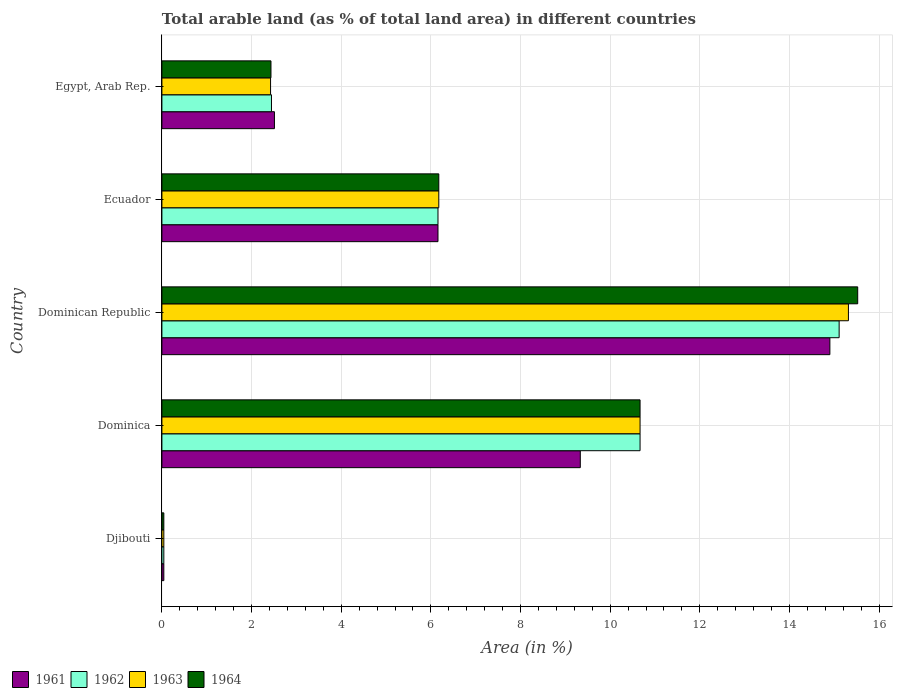How many different coloured bars are there?
Provide a short and direct response. 4. How many groups of bars are there?
Offer a terse response. 5. Are the number of bars on each tick of the Y-axis equal?
Your answer should be compact. Yes. How many bars are there on the 2nd tick from the top?
Keep it short and to the point. 4. What is the label of the 3rd group of bars from the top?
Provide a succinct answer. Dominican Republic. In how many cases, is the number of bars for a given country not equal to the number of legend labels?
Ensure brevity in your answer.  0. What is the percentage of arable land in 1964 in Dominica?
Your answer should be very brief. 10.67. Across all countries, what is the maximum percentage of arable land in 1961?
Provide a short and direct response. 14.9. Across all countries, what is the minimum percentage of arable land in 1962?
Offer a very short reply. 0.04. In which country was the percentage of arable land in 1961 maximum?
Your answer should be compact. Dominican Republic. In which country was the percentage of arable land in 1964 minimum?
Provide a short and direct response. Djibouti. What is the total percentage of arable land in 1961 in the graph?
Give a very brief answer. 32.95. What is the difference between the percentage of arable land in 1963 in Dominica and that in Dominican Republic?
Your answer should be very brief. -4.65. What is the difference between the percentage of arable land in 1963 in Egypt, Arab Rep. and the percentage of arable land in 1964 in Ecuador?
Your answer should be very brief. -3.75. What is the average percentage of arable land in 1961 per country?
Offer a terse response. 6.59. What is the difference between the percentage of arable land in 1961 and percentage of arable land in 1962 in Ecuador?
Your response must be concise. 0. In how many countries, is the percentage of arable land in 1963 greater than 6 %?
Offer a terse response. 3. What is the ratio of the percentage of arable land in 1961 in Ecuador to that in Egypt, Arab Rep.?
Give a very brief answer. 2.45. What is the difference between the highest and the second highest percentage of arable land in 1961?
Your answer should be compact. 5.57. What is the difference between the highest and the lowest percentage of arable land in 1961?
Give a very brief answer. 14.86. In how many countries, is the percentage of arable land in 1962 greater than the average percentage of arable land in 1962 taken over all countries?
Your answer should be compact. 2. Is it the case that in every country, the sum of the percentage of arable land in 1962 and percentage of arable land in 1964 is greater than the sum of percentage of arable land in 1963 and percentage of arable land in 1961?
Make the answer very short. No. What does the 3rd bar from the top in Djibouti represents?
Keep it short and to the point. 1962. Is it the case that in every country, the sum of the percentage of arable land in 1963 and percentage of arable land in 1964 is greater than the percentage of arable land in 1961?
Keep it short and to the point. Yes. How many bars are there?
Offer a terse response. 20. Are all the bars in the graph horizontal?
Keep it short and to the point. Yes. How many countries are there in the graph?
Keep it short and to the point. 5. What is the difference between two consecutive major ticks on the X-axis?
Make the answer very short. 2. Does the graph contain any zero values?
Keep it short and to the point. No. Does the graph contain grids?
Keep it short and to the point. Yes. How many legend labels are there?
Ensure brevity in your answer.  4. What is the title of the graph?
Ensure brevity in your answer.  Total arable land (as % of total land area) in different countries. What is the label or title of the X-axis?
Provide a succinct answer. Area (in %). What is the Area (in %) in 1961 in Djibouti?
Make the answer very short. 0.04. What is the Area (in %) of 1962 in Djibouti?
Provide a short and direct response. 0.04. What is the Area (in %) in 1963 in Djibouti?
Keep it short and to the point. 0.04. What is the Area (in %) in 1964 in Djibouti?
Give a very brief answer. 0.04. What is the Area (in %) of 1961 in Dominica?
Offer a very short reply. 9.33. What is the Area (in %) of 1962 in Dominica?
Provide a short and direct response. 10.67. What is the Area (in %) of 1963 in Dominica?
Make the answer very short. 10.67. What is the Area (in %) in 1964 in Dominica?
Offer a very short reply. 10.67. What is the Area (in %) in 1961 in Dominican Republic?
Offer a very short reply. 14.9. What is the Area (in %) in 1962 in Dominican Republic?
Keep it short and to the point. 15.11. What is the Area (in %) in 1963 in Dominican Republic?
Your answer should be compact. 15.31. What is the Area (in %) of 1964 in Dominican Republic?
Provide a succinct answer. 15.52. What is the Area (in %) of 1961 in Ecuador?
Your answer should be compact. 6.16. What is the Area (in %) in 1962 in Ecuador?
Offer a terse response. 6.16. What is the Area (in %) in 1963 in Ecuador?
Your answer should be very brief. 6.18. What is the Area (in %) in 1964 in Ecuador?
Ensure brevity in your answer.  6.18. What is the Area (in %) in 1961 in Egypt, Arab Rep.?
Provide a succinct answer. 2.51. What is the Area (in %) in 1962 in Egypt, Arab Rep.?
Your response must be concise. 2.44. What is the Area (in %) in 1963 in Egypt, Arab Rep.?
Offer a very short reply. 2.42. What is the Area (in %) of 1964 in Egypt, Arab Rep.?
Your answer should be compact. 2.43. Across all countries, what is the maximum Area (in %) in 1961?
Your response must be concise. 14.9. Across all countries, what is the maximum Area (in %) in 1962?
Your answer should be compact. 15.11. Across all countries, what is the maximum Area (in %) in 1963?
Make the answer very short. 15.31. Across all countries, what is the maximum Area (in %) in 1964?
Your answer should be very brief. 15.52. Across all countries, what is the minimum Area (in %) of 1961?
Keep it short and to the point. 0.04. Across all countries, what is the minimum Area (in %) in 1962?
Ensure brevity in your answer.  0.04. Across all countries, what is the minimum Area (in %) of 1963?
Offer a very short reply. 0.04. Across all countries, what is the minimum Area (in %) of 1964?
Provide a succinct answer. 0.04. What is the total Area (in %) of 1961 in the graph?
Give a very brief answer. 32.95. What is the total Area (in %) of 1962 in the graph?
Ensure brevity in your answer.  34.42. What is the total Area (in %) in 1963 in the graph?
Your answer should be very brief. 34.63. What is the total Area (in %) of 1964 in the graph?
Keep it short and to the point. 34.84. What is the difference between the Area (in %) of 1961 in Djibouti and that in Dominica?
Give a very brief answer. -9.29. What is the difference between the Area (in %) in 1962 in Djibouti and that in Dominica?
Give a very brief answer. -10.62. What is the difference between the Area (in %) in 1963 in Djibouti and that in Dominica?
Offer a very short reply. -10.62. What is the difference between the Area (in %) of 1964 in Djibouti and that in Dominica?
Keep it short and to the point. -10.62. What is the difference between the Area (in %) of 1961 in Djibouti and that in Dominican Republic?
Offer a very short reply. -14.86. What is the difference between the Area (in %) in 1962 in Djibouti and that in Dominican Republic?
Offer a very short reply. -15.06. What is the difference between the Area (in %) of 1963 in Djibouti and that in Dominican Republic?
Your answer should be compact. -15.27. What is the difference between the Area (in %) of 1964 in Djibouti and that in Dominican Republic?
Your response must be concise. -15.48. What is the difference between the Area (in %) in 1961 in Djibouti and that in Ecuador?
Offer a terse response. -6.12. What is the difference between the Area (in %) of 1962 in Djibouti and that in Ecuador?
Provide a succinct answer. -6.12. What is the difference between the Area (in %) of 1963 in Djibouti and that in Ecuador?
Provide a succinct answer. -6.13. What is the difference between the Area (in %) of 1964 in Djibouti and that in Ecuador?
Your answer should be compact. -6.13. What is the difference between the Area (in %) of 1961 in Djibouti and that in Egypt, Arab Rep.?
Offer a very short reply. -2.47. What is the difference between the Area (in %) of 1962 in Djibouti and that in Egypt, Arab Rep.?
Provide a succinct answer. -2.4. What is the difference between the Area (in %) in 1963 in Djibouti and that in Egypt, Arab Rep.?
Your answer should be very brief. -2.38. What is the difference between the Area (in %) of 1964 in Djibouti and that in Egypt, Arab Rep.?
Your response must be concise. -2.39. What is the difference between the Area (in %) of 1961 in Dominica and that in Dominican Republic?
Offer a very short reply. -5.57. What is the difference between the Area (in %) in 1962 in Dominica and that in Dominican Republic?
Offer a very short reply. -4.44. What is the difference between the Area (in %) in 1963 in Dominica and that in Dominican Republic?
Offer a very short reply. -4.65. What is the difference between the Area (in %) in 1964 in Dominica and that in Dominican Republic?
Provide a short and direct response. -4.85. What is the difference between the Area (in %) of 1961 in Dominica and that in Ecuador?
Provide a succinct answer. 3.17. What is the difference between the Area (in %) in 1962 in Dominica and that in Ecuador?
Provide a succinct answer. 4.51. What is the difference between the Area (in %) of 1963 in Dominica and that in Ecuador?
Ensure brevity in your answer.  4.49. What is the difference between the Area (in %) in 1964 in Dominica and that in Ecuador?
Your answer should be compact. 4.49. What is the difference between the Area (in %) in 1961 in Dominica and that in Egypt, Arab Rep.?
Offer a very short reply. 6.82. What is the difference between the Area (in %) of 1962 in Dominica and that in Egypt, Arab Rep.?
Your response must be concise. 8.22. What is the difference between the Area (in %) of 1963 in Dominica and that in Egypt, Arab Rep.?
Offer a terse response. 8.24. What is the difference between the Area (in %) of 1964 in Dominica and that in Egypt, Arab Rep.?
Your response must be concise. 8.23. What is the difference between the Area (in %) of 1961 in Dominican Republic and that in Ecuador?
Provide a short and direct response. 8.74. What is the difference between the Area (in %) in 1962 in Dominican Republic and that in Ecuador?
Keep it short and to the point. 8.95. What is the difference between the Area (in %) of 1963 in Dominican Republic and that in Ecuador?
Provide a short and direct response. 9.14. What is the difference between the Area (in %) in 1964 in Dominican Republic and that in Ecuador?
Ensure brevity in your answer.  9.34. What is the difference between the Area (in %) of 1961 in Dominican Republic and that in Egypt, Arab Rep.?
Provide a succinct answer. 12.39. What is the difference between the Area (in %) in 1962 in Dominican Republic and that in Egypt, Arab Rep.?
Provide a succinct answer. 12.66. What is the difference between the Area (in %) of 1963 in Dominican Republic and that in Egypt, Arab Rep.?
Keep it short and to the point. 12.89. What is the difference between the Area (in %) of 1964 in Dominican Republic and that in Egypt, Arab Rep.?
Your answer should be compact. 13.09. What is the difference between the Area (in %) in 1961 in Ecuador and that in Egypt, Arab Rep.?
Keep it short and to the point. 3.65. What is the difference between the Area (in %) in 1962 in Ecuador and that in Egypt, Arab Rep.?
Provide a short and direct response. 3.71. What is the difference between the Area (in %) in 1963 in Ecuador and that in Egypt, Arab Rep.?
Make the answer very short. 3.75. What is the difference between the Area (in %) in 1964 in Ecuador and that in Egypt, Arab Rep.?
Ensure brevity in your answer.  3.74. What is the difference between the Area (in %) in 1961 in Djibouti and the Area (in %) in 1962 in Dominica?
Make the answer very short. -10.62. What is the difference between the Area (in %) of 1961 in Djibouti and the Area (in %) of 1963 in Dominica?
Provide a short and direct response. -10.62. What is the difference between the Area (in %) of 1961 in Djibouti and the Area (in %) of 1964 in Dominica?
Ensure brevity in your answer.  -10.62. What is the difference between the Area (in %) in 1962 in Djibouti and the Area (in %) in 1963 in Dominica?
Keep it short and to the point. -10.62. What is the difference between the Area (in %) of 1962 in Djibouti and the Area (in %) of 1964 in Dominica?
Give a very brief answer. -10.62. What is the difference between the Area (in %) of 1963 in Djibouti and the Area (in %) of 1964 in Dominica?
Offer a very short reply. -10.62. What is the difference between the Area (in %) in 1961 in Djibouti and the Area (in %) in 1962 in Dominican Republic?
Offer a very short reply. -15.06. What is the difference between the Area (in %) of 1961 in Djibouti and the Area (in %) of 1963 in Dominican Republic?
Offer a terse response. -15.27. What is the difference between the Area (in %) of 1961 in Djibouti and the Area (in %) of 1964 in Dominican Republic?
Keep it short and to the point. -15.48. What is the difference between the Area (in %) in 1962 in Djibouti and the Area (in %) in 1963 in Dominican Republic?
Provide a short and direct response. -15.27. What is the difference between the Area (in %) in 1962 in Djibouti and the Area (in %) in 1964 in Dominican Republic?
Provide a succinct answer. -15.48. What is the difference between the Area (in %) in 1963 in Djibouti and the Area (in %) in 1964 in Dominican Republic?
Make the answer very short. -15.48. What is the difference between the Area (in %) of 1961 in Djibouti and the Area (in %) of 1962 in Ecuador?
Provide a short and direct response. -6.12. What is the difference between the Area (in %) in 1961 in Djibouti and the Area (in %) in 1963 in Ecuador?
Provide a succinct answer. -6.13. What is the difference between the Area (in %) of 1961 in Djibouti and the Area (in %) of 1964 in Ecuador?
Your answer should be compact. -6.13. What is the difference between the Area (in %) of 1962 in Djibouti and the Area (in %) of 1963 in Ecuador?
Your answer should be compact. -6.13. What is the difference between the Area (in %) of 1962 in Djibouti and the Area (in %) of 1964 in Ecuador?
Provide a succinct answer. -6.13. What is the difference between the Area (in %) of 1963 in Djibouti and the Area (in %) of 1964 in Ecuador?
Your response must be concise. -6.13. What is the difference between the Area (in %) in 1961 in Djibouti and the Area (in %) in 1962 in Egypt, Arab Rep.?
Your answer should be very brief. -2.4. What is the difference between the Area (in %) of 1961 in Djibouti and the Area (in %) of 1963 in Egypt, Arab Rep.?
Offer a terse response. -2.38. What is the difference between the Area (in %) in 1961 in Djibouti and the Area (in %) in 1964 in Egypt, Arab Rep.?
Your response must be concise. -2.39. What is the difference between the Area (in %) of 1962 in Djibouti and the Area (in %) of 1963 in Egypt, Arab Rep.?
Offer a terse response. -2.38. What is the difference between the Area (in %) in 1962 in Djibouti and the Area (in %) in 1964 in Egypt, Arab Rep.?
Ensure brevity in your answer.  -2.39. What is the difference between the Area (in %) of 1963 in Djibouti and the Area (in %) of 1964 in Egypt, Arab Rep.?
Give a very brief answer. -2.39. What is the difference between the Area (in %) in 1961 in Dominica and the Area (in %) in 1962 in Dominican Republic?
Your answer should be compact. -5.77. What is the difference between the Area (in %) of 1961 in Dominica and the Area (in %) of 1963 in Dominican Republic?
Make the answer very short. -5.98. What is the difference between the Area (in %) in 1961 in Dominica and the Area (in %) in 1964 in Dominican Republic?
Your answer should be very brief. -6.19. What is the difference between the Area (in %) of 1962 in Dominica and the Area (in %) of 1963 in Dominican Republic?
Make the answer very short. -4.65. What is the difference between the Area (in %) in 1962 in Dominica and the Area (in %) in 1964 in Dominican Republic?
Offer a terse response. -4.85. What is the difference between the Area (in %) in 1963 in Dominica and the Area (in %) in 1964 in Dominican Republic?
Offer a very short reply. -4.85. What is the difference between the Area (in %) of 1961 in Dominica and the Area (in %) of 1962 in Ecuador?
Offer a terse response. 3.17. What is the difference between the Area (in %) of 1961 in Dominica and the Area (in %) of 1963 in Ecuador?
Your answer should be very brief. 3.16. What is the difference between the Area (in %) in 1961 in Dominica and the Area (in %) in 1964 in Ecuador?
Your response must be concise. 3.16. What is the difference between the Area (in %) of 1962 in Dominica and the Area (in %) of 1963 in Ecuador?
Your answer should be compact. 4.49. What is the difference between the Area (in %) of 1962 in Dominica and the Area (in %) of 1964 in Ecuador?
Provide a short and direct response. 4.49. What is the difference between the Area (in %) of 1963 in Dominica and the Area (in %) of 1964 in Ecuador?
Provide a succinct answer. 4.49. What is the difference between the Area (in %) of 1961 in Dominica and the Area (in %) of 1962 in Egypt, Arab Rep.?
Keep it short and to the point. 6.89. What is the difference between the Area (in %) in 1961 in Dominica and the Area (in %) in 1963 in Egypt, Arab Rep.?
Offer a very short reply. 6.91. What is the difference between the Area (in %) in 1961 in Dominica and the Area (in %) in 1964 in Egypt, Arab Rep.?
Your answer should be compact. 6.9. What is the difference between the Area (in %) in 1962 in Dominica and the Area (in %) in 1963 in Egypt, Arab Rep.?
Keep it short and to the point. 8.24. What is the difference between the Area (in %) of 1962 in Dominica and the Area (in %) of 1964 in Egypt, Arab Rep.?
Provide a succinct answer. 8.23. What is the difference between the Area (in %) of 1963 in Dominica and the Area (in %) of 1964 in Egypt, Arab Rep.?
Offer a very short reply. 8.23. What is the difference between the Area (in %) in 1961 in Dominican Republic and the Area (in %) in 1962 in Ecuador?
Your answer should be very brief. 8.74. What is the difference between the Area (in %) of 1961 in Dominican Republic and the Area (in %) of 1963 in Ecuador?
Keep it short and to the point. 8.72. What is the difference between the Area (in %) in 1961 in Dominican Republic and the Area (in %) in 1964 in Ecuador?
Your response must be concise. 8.72. What is the difference between the Area (in %) of 1962 in Dominican Republic and the Area (in %) of 1963 in Ecuador?
Keep it short and to the point. 8.93. What is the difference between the Area (in %) in 1962 in Dominican Republic and the Area (in %) in 1964 in Ecuador?
Provide a succinct answer. 8.93. What is the difference between the Area (in %) of 1963 in Dominican Republic and the Area (in %) of 1964 in Ecuador?
Keep it short and to the point. 9.14. What is the difference between the Area (in %) of 1961 in Dominican Republic and the Area (in %) of 1962 in Egypt, Arab Rep.?
Offer a very short reply. 12.46. What is the difference between the Area (in %) in 1961 in Dominican Republic and the Area (in %) in 1963 in Egypt, Arab Rep.?
Offer a very short reply. 12.48. What is the difference between the Area (in %) of 1961 in Dominican Republic and the Area (in %) of 1964 in Egypt, Arab Rep.?
Make the answer very short. 12.47. What is the difference between the Area (in %) in 1962 in Dominican Republic and the Area (in %) in 1963 in Egypt, Arab Rep.?
Offer a terse response. 12.68. What is the difference between the Area (in %) in 1962 in Dominican Republic and the Area (in %) in 1964 in Egypt, Arab Rep.?
Make the answer very short. 12.67. What is the difference between the Area (in %) of 1963 in Dominican Republic and the Area (in %) of 1964 in Egypt, Arab Rep.?
Offer a terse response. 12.88. What is the difference between the Area (in %) in 1961 in Ecuador and the Area (in %) in 1962 in Egypt, Arab Rep.?
Your answer should be compact. 3.71. What is the difference between the Area (in %) of 1961 in Ecuador and the Area (in %) of 1963 in Egypt, Arab Rep.?
Your answer should be very brief. 3.73. What is the difference between the Area (in %) of 1961 in Ecuador and the Area (in %) of 1964 in Egypt, Arab Rep.?
Keep it short and to the point. 3.73. What is the difference between the Area (in %) of 1962 in Ecuador and the Area (in %) of 1963 in Egypt, Arab Rep.?
Provide a succinct answer. 3.73. What is the difference between the Area (in %) of 1962 in Ecuador and the Area (in %) of 1964 in Egypt, Arab Rep.?
Make the answer very short. 3.73. What is the difference between the Area (in %) in 1963 in Ecuador and the Area (in %) in 1964 in Egypt, Arab Rep.?
Provide a succinct answer. 3.74. What is the average Area (in %) in 1961 per country?
Offer a very short reply. 6.59. What is the average Area (in %) in 1962 per country?
Your response must be concise. 6.88. What is the average Area (in %) of 1963 per country?
Ensure brevity in your answer.  6.93. What is the average Area (in %) in 1964 per country?
Your answer should be very brief. 6.97. What is the difference between the Area (in %) in 1961 and Area (in %) in 1962 in Dominica?
Your answer should be very brief. -1.33. What is the difference between the Area (in %) in 1961 and Area (in %) in 1963 in Dominica?
Make the answer very short. -1.33. What is the difference between the Area (in %) in 1961 and Area (in %) in 1964 in Dominica?
Make the answer very short. -1.33. What is the difference between the Area (in %) of 1962 and Area (in %) of 1963 in Dominica?
Your answer should be very brief. 0. What is the difference between the Area (in %) of 1963 and Area (in %) of 1964 in Dominica?
Your answer should be compact. 0. What is the difference between the Area (in %) in 1961 and Area (in %) in 1962 in Dominican Republic?
Offer a very short reply. -0.21. What is the difference between the Area (in %) in 1961 and Area (in %) in 1963 in Dominican Republic?
Make the answer very short. -0.41. What is the difference between the Area (in %) of 1961 and Area (in %) of 1964 in Dominican Republic?
Provide a short and direct response. -0.62. What is the difference between the Area (in %) in 1962 and Area (in %) in 1963 in Dominican Republic?
Ensure brevity in your answer.  -0.21. What is the difference between the Area (in %) in 1962 and Area (in %) in 1964 in Dominican Republic?
Your answer should be compact. -0.41. What is the difference between the Area (in %) of 1963 and Area (in %) of 1964 in Dominican Republic?
Your answer should be compact. -0.21. What is the difference between the Area (in %) in 1961 and Area (in %) in 1963 in Ecuador?
Keep it short and to the point. -0.02. What is the difference between the Area (in %) in 1961 and Area (in %) in 1964 in Ecuador?
Make the answer very short. -0.02. What is the difference between the Area (in %) in 1962 and Area (in %) in 1963 in Ecuador?
Your answer should be very brief. -0.02. What is the difference between the Area (in %) in 1962 and Area (in %) in 1964 in Ecuador?
Your answer should be compact. -0.02. What is the difference between the Area (in %) of 1961 and Area (in %) of 1962 in Egypt, Arab Rep.?
Make the answer very short. 0.07. What is the difference between the Area (in %) of 1961 and Area (in %) of 1963 in Egypt, Arab Rep.?
Provide a succinct answer. 0.09. What is the difference between the Area (in %) in 1961 and Area (in %) in 1964 in Egypt, Arab Rep.?
Keep it short and to the point. 0.08. What is the difference between the Area (in %) of 1962 and Area (in %) of 1963 in Egypt, Arab Rep.?
Provide a short and direct response. 0.02. What is the difference between the Area (in %) in 1962 and Area (in %) in 1964 in Egypt, Arab Rep.?
Give a very brief answer. 0.01. What is the difference between the Area (in %) of 1963 and Area (in %) of 1964 in Egypt, Arab Rep.?
Make the answer very short. -0.01. What is the ratio of the Area (in %) in 1961 in Djibouti to that in Dominica?
Provide a short and direct response. 0. What is the ratio of the Area (in %) of 1962 in Djibouti to that in Dominica?
Your answer should be very brief. 0. What is the ratio of the Area (in %) of 1963 in Djibouti to that in Dominica?
Provide a succinct answer. 0. What is the ratio of the Area (in %) in 1964 in Djibouti to that in Dominica?
Your answer should be compact. 0. What is the ratio of the Area (in %) of 1961 in Djibouti to that in Dominican Republic?
Your response must be concise. 0. What is the ratio of the Area (in %) of 1962 in Djibouti to that in Dominican Republic?
Offer a very short reply. 0. What is the ratio of the Area (in %) in 1963 in Djibouti to that in Dominican Republic?
Offer a terse response. 0. What is the ratio of the Area (in %) of 1964 in Djibouti to that in Dominican Republic?
Give a very brief answer. 0. What is the ratio of the Area (in %) in 1961 in Djibouti to that in Ecuador?
Provide a succinct answer. 0.01. What is the ratio of the Area (in %) of 1962 in Djibouti to that in Ecuador?
Give a very brief answer. 0.01. What is the ratio of the Area (in %) of 1963 in Djibouti to that in Ecuador?
Your answer should be compact. 0.01. What is the ratio of the Area (in %) in 1964 in Djibouti to that in Ecuador?
Your answer should be very brief. 0.01. What is the ratio of the Area (in %) in 1961 in Djibouti to that in Egypt, Arab Rep.?
Provide a succinct answer. 0.02. What is the ratio of the Area (in %) in 1962 in Djibouti to that in Egypt, Arab Rep.?
Provide a short and direct response. 0.02. What is the ratio of the Area (in %) in 1963 in Djibouti to that in Egypt, Arab Rep.?
Provide a short and direct response. 0.02. What is the ratio of the Area (in %) of 1964 in Djibouti to that in Egypt, Arab Rep.?
Give a very brief answer. 0.02. What is the ratio of the Area (in %) in 1961 in Dominica to that in Dominican Republic?
Your answer should be compact. 0.63. What is the ratio of the Area (in %) of 1962 in Dominica to that in Dominican Republic?
Provide a succinct answer. 0.71. What is the ratio of the Area (in %) in 1963 in Dominica to that in Dominican Republic?
Offer a very short reply. 0.7. What is the ratio of the Area (in %) of 1964 in Dominica to that in Dominican Republic?
Keep it short and to the point. 0.69. What is the ratio of the Area (in %) of 1961 in Dominica to that in Ecuador?
Keep it short and to the point. 1.52. What is the ratio of the Area (in %) in 1962 in Dominica to that in Ecuador?
Offer a very short reply. 1.73. What is the ratio of the Area (in %) of 1963 in Dominica to that in Ecuador?
Your answer should be compact. 1.73. What is the ratio of the Area (in %) of 1964 in Dominica to that in Ecuador?
Offer a terse response. 1.73. What is the ratio of the Area (in %) of 1961 in Dominica to that in Egypt, Arab Rep.?
Provide a short and direct response. 3.72. What is the ratio of the Area (in %) in 1962 in Dominica to that in Egypt, Arab Rep.?
Offer a terse response. 4.36. What is the ratio of the Area (in %) in 1963 in Dominica to that in Egypt, Arab Rep.?
Give a very brief answer. 4.4. What is the ratio of the Area (in %) in 1964 in Dominica to that in Egypt, Arab Rep.?
Offer a very short reply. 4.38. What is the ratio of the Area (in %) in 1961 in Dominican Republic to that in Ecuador?
Offer a very short reply. 2.42. What is the ratio of the Area (in %) of 1962 in Dominican Republic to that in Ecuador?
Offer a terse response. 2.45. What is the ratio of the Area (in %) of 1963 in Dominican Republic to that in Ecuador?
Offer a terse response. 2.48. What is the ratio of the Area (in %) of 1964 in Dominican Republic to that in Ecuador?
Provide a succinct answer. 2.51. What is the ratio of the Area (in %) of 1961 in Dominican Republic to that in Egypt, Arab Rep.?
Your answer should be very brief. 5.94. What is the ratio of the Area (in %) of 1962 in Dominican Republic to that in Egypt, Arab Rep.?
Provide a succinct answer. 6.18. What is the ratio of the Area (in %) of 1963 in Dominican Republic to that in Egypt, Arab Rep.?
Your answer should be very brief. 6.32. What is the ratio of the Area (in %) in 1964 in Dominican Republic to that in Egypt, Arab Rep.?
Your answer should be compact. 6.38. What is the ratio of the Area (in %) in 1961 in Ecuador to that in Egypt, Arab Rep.?
Make the answer very short. 2.45. What is the ratio of the Area (in %) in 1962 in Ecuador to that in Egypt, Arab Rep.?
Keep it short and to the point. 2.52. What is the ratio of the Area (in %) of 1963 in Ecuador to that in Egypt, Arab Rep.?
Your answer should be very brief. 2.55. What is the ratio of the Area (in %) of 1964 in Ecuador to that in Egypt, Arab Rep.?
Your response must be concise. 2.54. What is the difference between the highest and the second highest Area (in %) in 1961?
Offer a very short reply. 5.57. What is the difference between the highest and the second highest Area (in %) in 1962?
Offer a terse response. 4.44. What is the difference between the highest and the second highest Area (in %) of 1963?
Make the answer very short. 4.65. What is the difference between the highest and the second highest Area (in %) in 1964?
Ensure brevity in your answer.  4.85. What is the difference between the highest and the lowest Area (in %) in 1961?
Offer a terse response. 14.86. What is the difference between the highest and the lowest Area (in %) of 1962?
Provide a succinct answer. 15.06. What is the difference between the highest and the lowest Area (in %) of 1963?
Ensure brevity in your answer.  15.27. What is the difference between the highest and the lowest Area (in %) of 1964?
Provide a short and direct response. 15.48. 